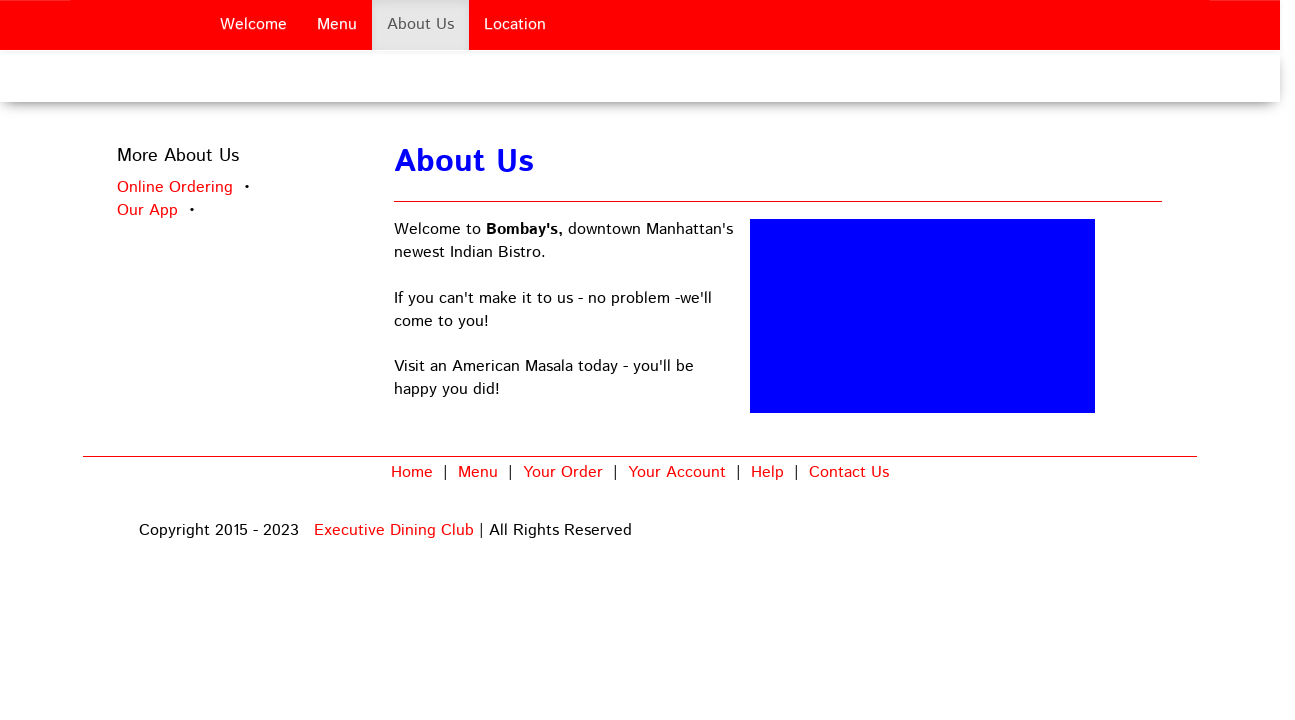What inspired the design choice of using a primarily red and blue color scheme for this page? The choice of a red and blue color scheme for the webpage might be motivated by a desire to evoke a sense of vibrancy and trust. Red is often associated with energy and passion, which could reflect the restaurant's lively atmosphere, while blue might represent trustworthiness and reliability, suggesting a dependable dining experience. 